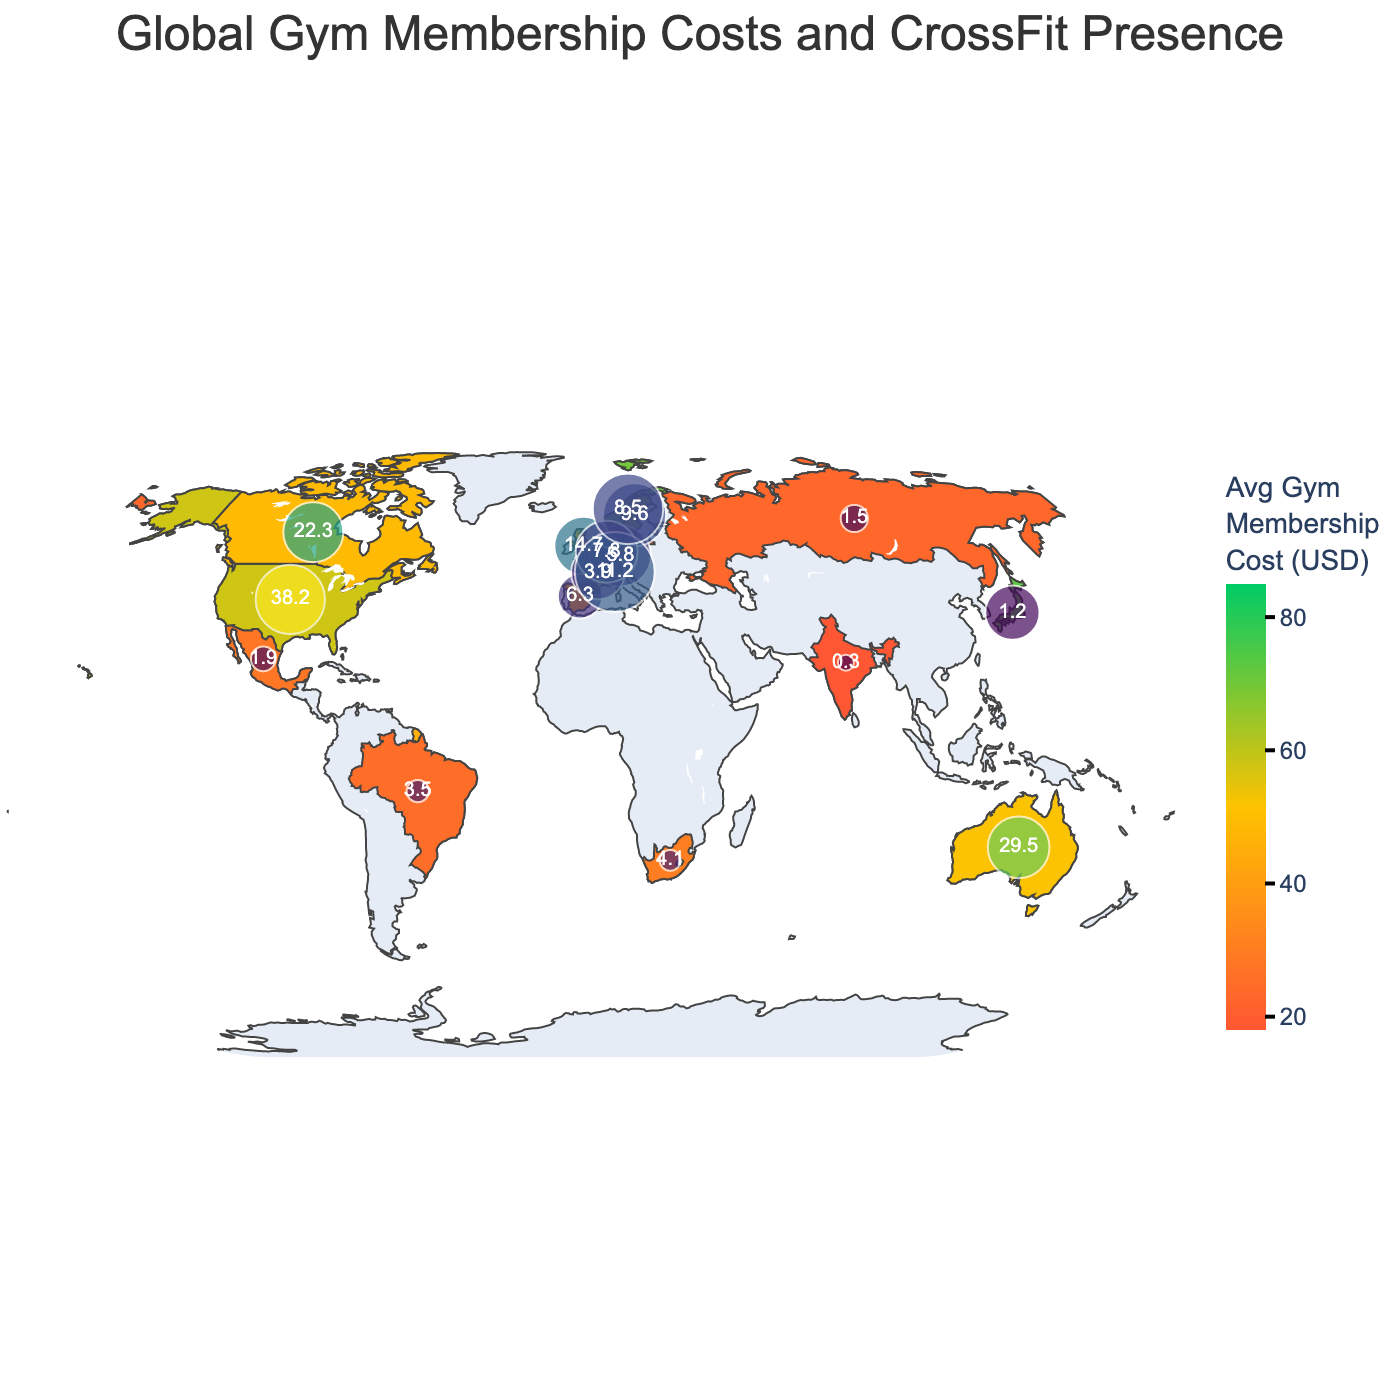What is the title of the map? The title of the map is typically placed at the top and describes the content presented. In this case, the title provided in the code is "Global Gym Membership Costs and CrossFit Presence".
Answer: Global Gym Membership Costs and CrossFit Presence Which country has the highest average gym membership cost? Locate the country with the deepest or most intense color, which indicates the highest value on the color scale for "Avg_Gym_Membership_Cost_USD". According to the data, Singapore has the highest cost of $85.
Answer: Singapore How many countries have average gym membership costs above 50 USD? Identify and count the countries with colors representing costs above 50 USD. The countries are the United States, Australia, Japan, Sweden, Switzerland, Norway, and Singapore.
Answer: 7 Which country has the most CrossFit boxes per million population? The size and color intensity of the scatter plot markers represent CrossFit density. The US has the highest value noted in the additional scatter plot data.
Answer: United States Compare the GDP per capita for Germany and Spain. Which is higher and by how much? Check the hover data or marker sizes for both Germany and Spain. Germany's GDP per capita is $51,203, and Spain's is $27,056. The difference is $51,203 - $27,056.
Answer: Germany, by $24,147 Which country has the lowest GDP per capita? Find the country with the smallest marker indicating the lowest GDP per capita. According to the data, India has the lowest GDP per capita.
Answer: India What is the average gym membership cost for countries with CrossFit boxes per million above 10? Identify the relevant countries (US, UK, Australia, Canada, Sweden, Switzerland) and average their gym membership costs (58, 44, 52, 49, 64, 81). Calculate (58+44+52+49+64+81)/6 = 58 USD.
Answer: 58 USD How does the gym membership cost in Canada compare to that in the United Kingdom? Check the color intensity or value for both countries. Canada has an average cost of $49, while the UK has $44. Canada is $5 more expensive than the UK.
Answer: Canada is $5 more What is the range of average gym membership costs across the countries listed? Determine the minimum ($18, India) and maximum ($85, Singapore) values, then find the range by subtracting the minimum from the maximum.
Answer: $67 